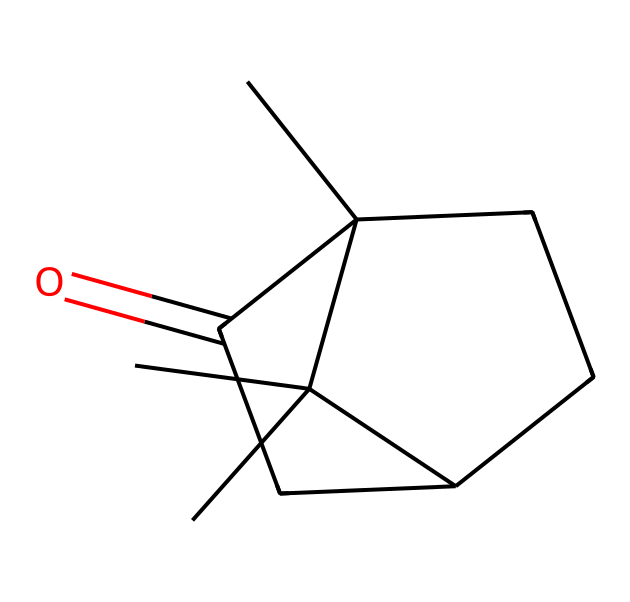What is the main functional group present in this chemical? The structural formula shows a carbonyl group (C=O) attached to a carbon chain, which characterizes ketones.
Answer: carbonyl How many carbon atoms are in camphor? By analyzing the SMILES representation, there are a total of 10 carbon atoms present in the structure.
Answer: ten What type of isomerism is exhibited by camphor? The structure suggests the presence of stereocenters, indicating that camphor can exhibit stereoisomerism due to the arrangement of atoms around those centers.
Answer: stereoisomerism What is the molecular formula for camphor? By counting the constituents derived from the SMILES representation, camphor has the molecular formula C10H16O, summarizing its composition of carbon, hydrogen, and oxygen.
Answer: C10H16O What type of molecular structure does camphor have? The chemical structure indicates a cyclic arrangement with additional carbon branching, classifying it as a bicyclic compound.
Answer: bicyclic What is the significance of the ketone functional group in camphor? Ketones, such as camphor, are known for their distinctive aromas and medicinal properties, including anti-inflammatory effects and use in traditional medicine, particularly in various cultures.
Answer: medicinal properties 